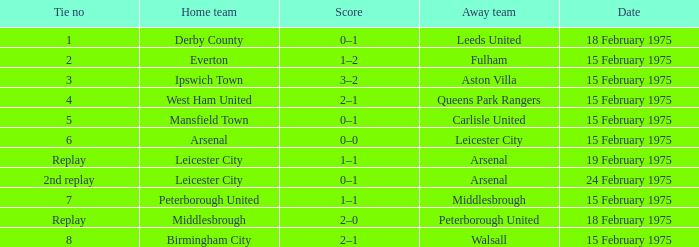What was the date when the away team was carlisle united? 15 February 1975. 